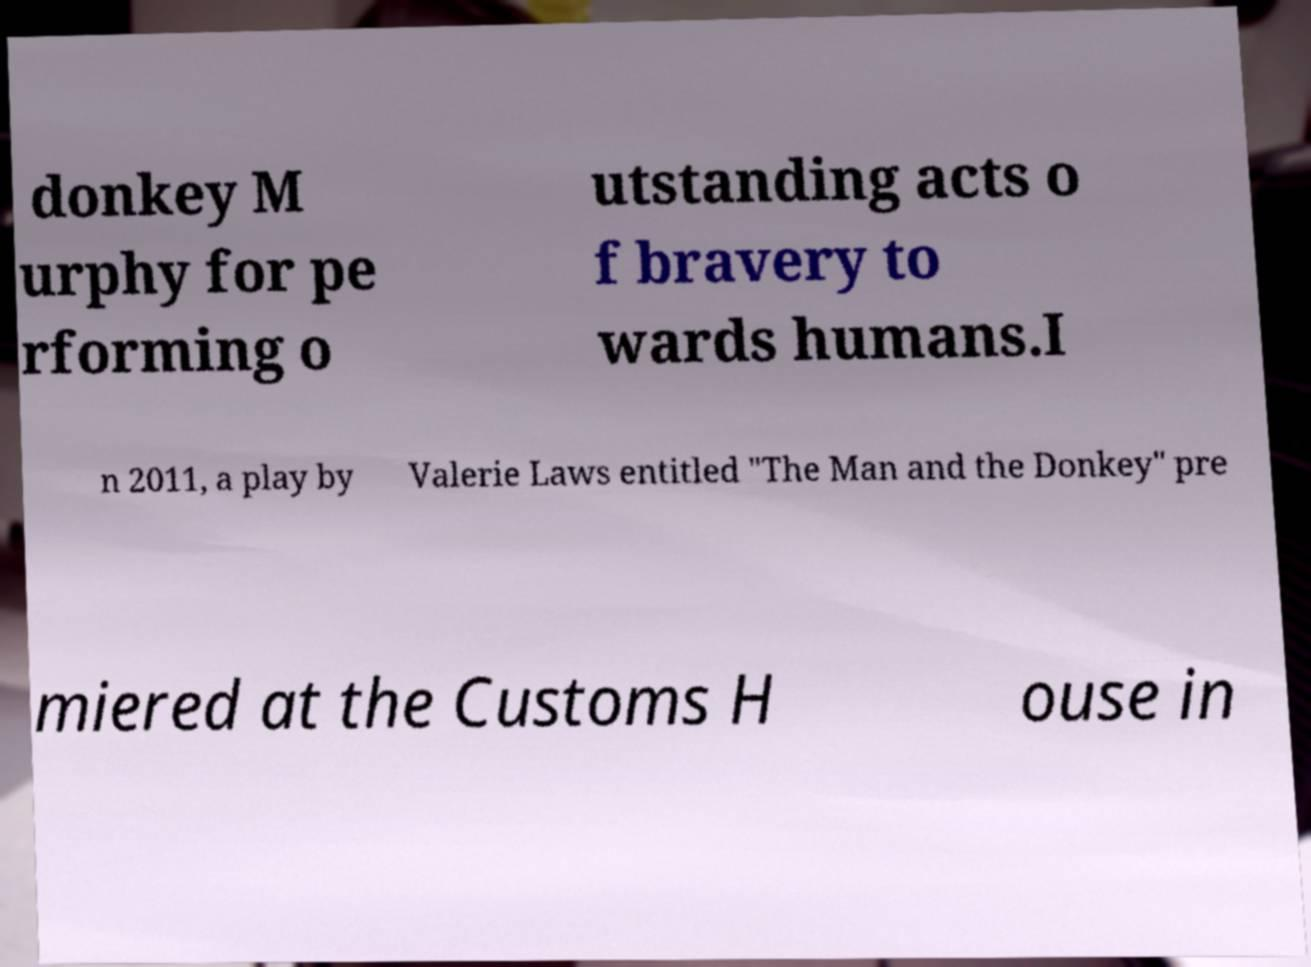Could you extract and type out the text from this image? donkey M urphy for pe rforming o utstanding acts o f bravery to wards humans.I n 2011, a play by Valerie Laws entitled "The Man and the Donkey" pre miered at the Customs H ouse in 